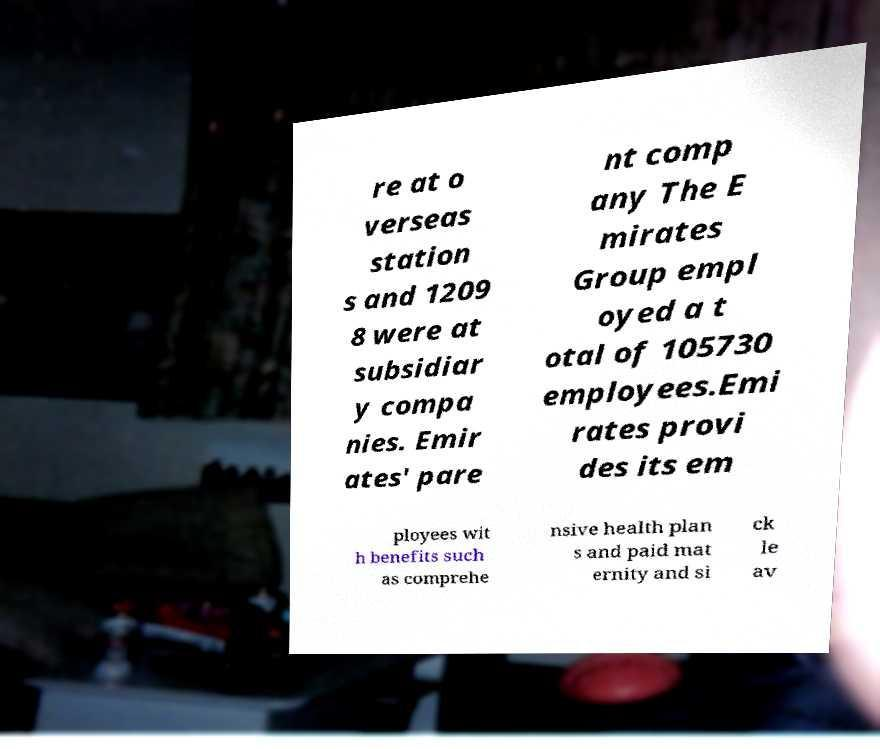Please identify and transcribe the text found in this image. re at o verseas station s and 1209 8 were at subsidiar y compa nies. Emir ates' pare nt comp any The E mirates Group empl oyed a t otal of 105730 employees.Emi rates provi des its em ployees wit h benefits such as comprehe nsive health plan s and paid mat ernity and si ck le av 